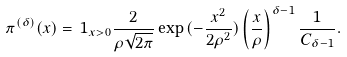Convert formula to latex. <formula><loc_0><loc_0><loc_500><loc_500>\pi ^ { ( \delta ) } ( x ) = \, 1 _ { x > 0 } \frac { 2 } { \rho \sqrt { 2 \pi } } \exp { ( - \frac { x ^ { 2 } } { 2 \rho ^ { 2 } } ) } \left ( \frac { x } { \rho } \right ) ^ { \delta - 1 } \frac { 1 } { C _ { \delta - 1 } } .</formula> 